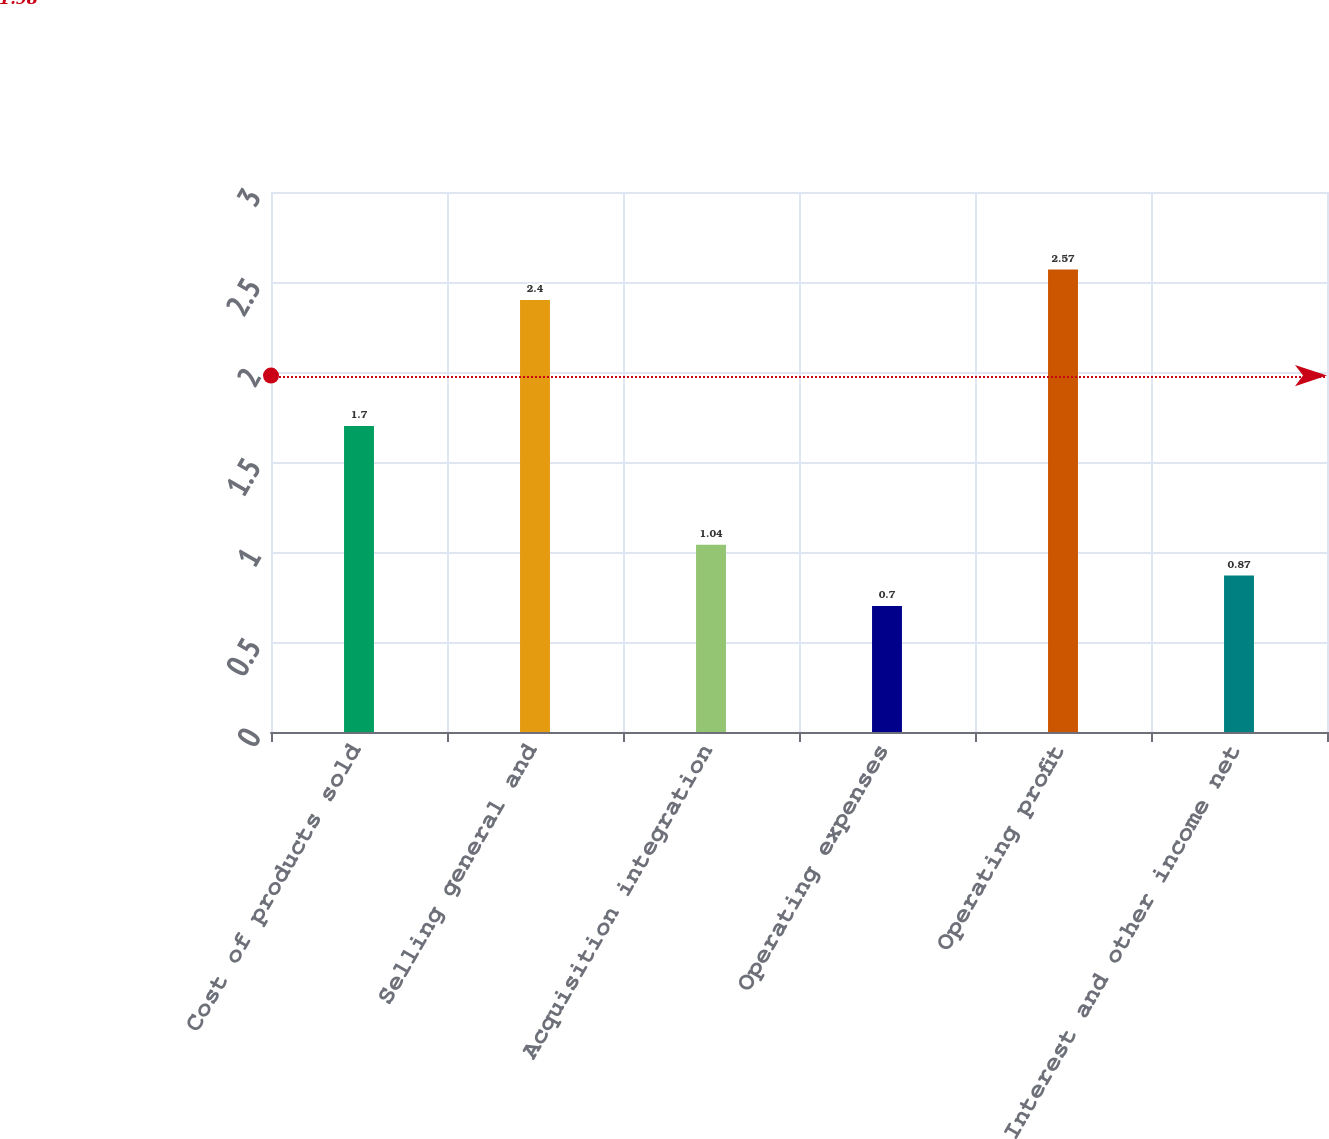<chart> <loc_0><loc_0><loc_500><loc_500><bar_chart><fcel>Cost of products sold<fcel>Selling general and<fcel>Acquisition integration<fcel>Operating expenses<fcel>Operating profit<fcel>Interest and other income net<nl><fcel>1.7<fcel>2.4<fcel>1.04<fcel>0.7<fcel>2.57<fcel>0.87<nl></chart> 